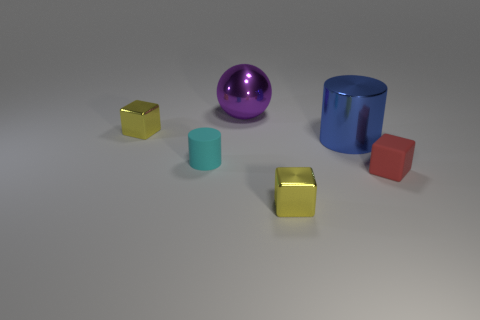Add 1 tiny yellow matte blocks. How many objects exist? 7 Subtract all balls. How many objects are left? 5 Subtract all small brown metallic cubes. Subtract all yellow blocks. How many objects are left? 4 Add 6 yellow objects. How many yellow objects are left? 8 Add 2 big metallic spheres. How many big metallic spheres exist? 3 Subtract 0 yellow cylinders. How many objects are left? 6 